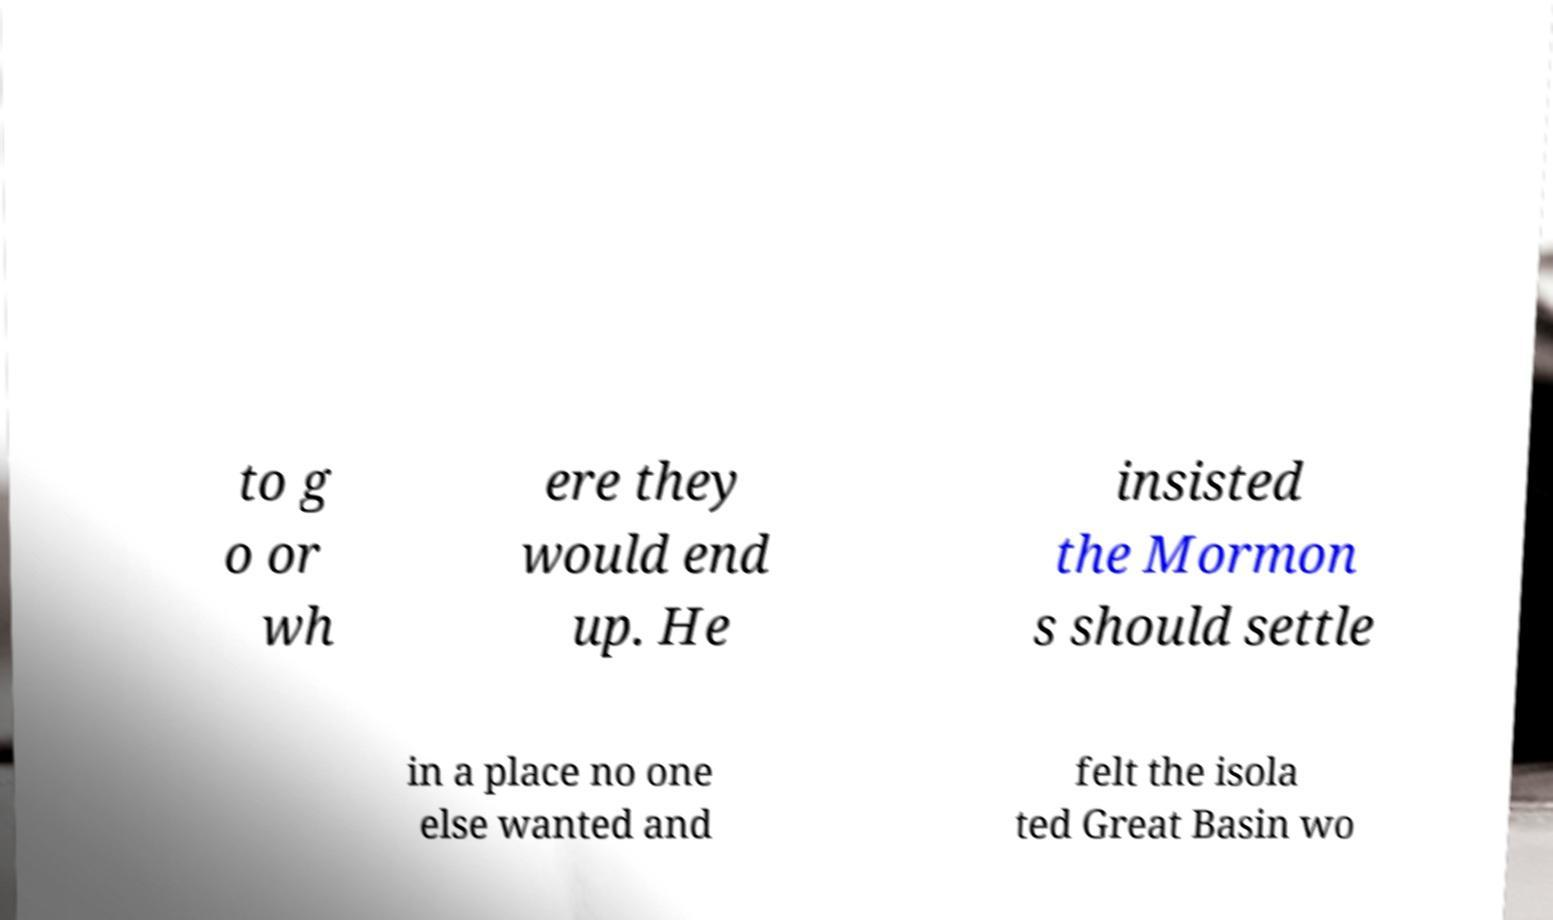What messages or text are displayed in this image? I need them in a readable, typed format. to g o or wh ere they would end up. He insisted the Mormon s should settle in a place no one else wanted and felt the isola ted Great Basin wo 